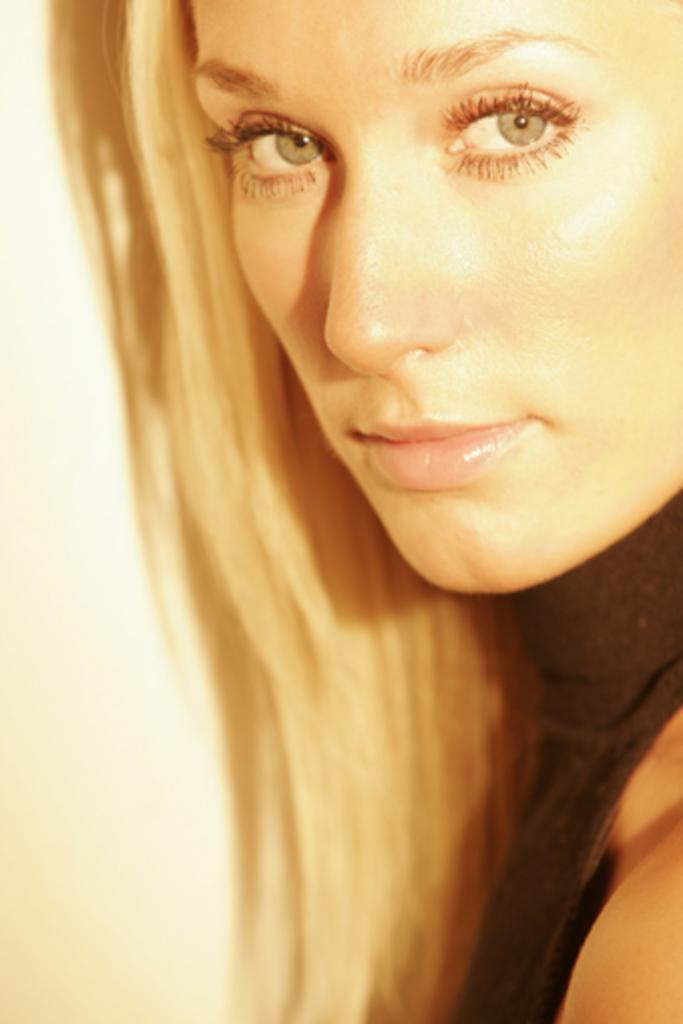Who is the main subject in the image? There is a woman in the image. What expression does the woman have? The woman is smiling. What can be seen in the background of the image? There is a wall in the background of the image. What type of roll is the woman holding in the image? There is no roll present in the image; the woman is simply smiling. 